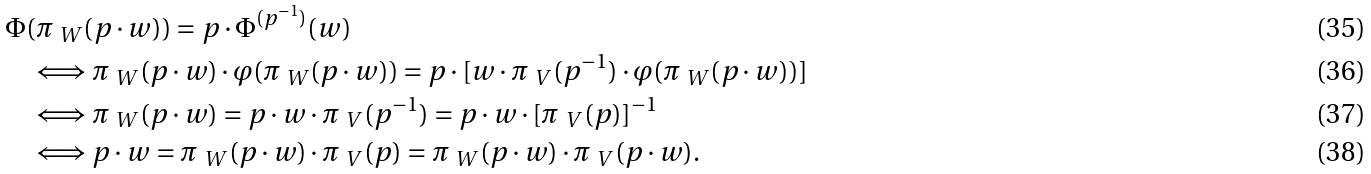Convert formula to latex. <formula><loc_0><loc_0><loc_500><loc_500>& \Phi ( \pi _ { \ W } ( p \cdot w ) ) = p \cdot \Phi ^ { ( p ^ { - 1 } ) } ( w ) \\ & \quad \Longleftrightarrow \pi _ { \ W } ( p \cdot w ) \cdot \varphi ( \pi _ { \ W } ( p \cdot w ) ) = p \cdot [ w \cdot \pi _ { \ V } ( p ^ { - 1 } ) \cdot \varphi ( \pi _ { \ W } ( p \cdot w ) ) ] \\ & \quad \Longleftrightarrow \pi _ { \ W } ( p \cdot w ) = p \cdot w \cdot \pi _ { \ V } ( p ^ { - 1 } ) = p \cdot w \cdot [ \pi _ { \ V } ( p ) ] ^ { - 1 } \\ & \quad \Longleftrightarrow p \cdot w = \pi _ { \ W } ( p \cdot w ) \cdot \pi _ { \ V } ( p ) = \pi _ { \ W } ( p \cdot w ) \cdot \pi _ { \ V } ( p \cdot w ) .</formula> 